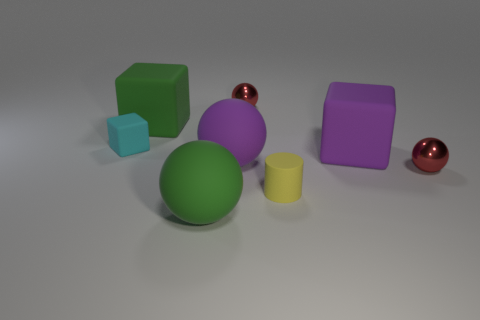Add 1 purple rubber spheres. How many objects exist? 9 Subtract all blocks. How many objects are left? 5 Subtract all tiny cyan shiny things. Subtract all green blocks. How many objects are left? 7 Add 1 cyan rubber objects. How many cyan rubber objects are left? 2 Add 4 large blocks. How many large blocks exist? 6 Subtract 0 blue cubes. How many objects are left? 8 